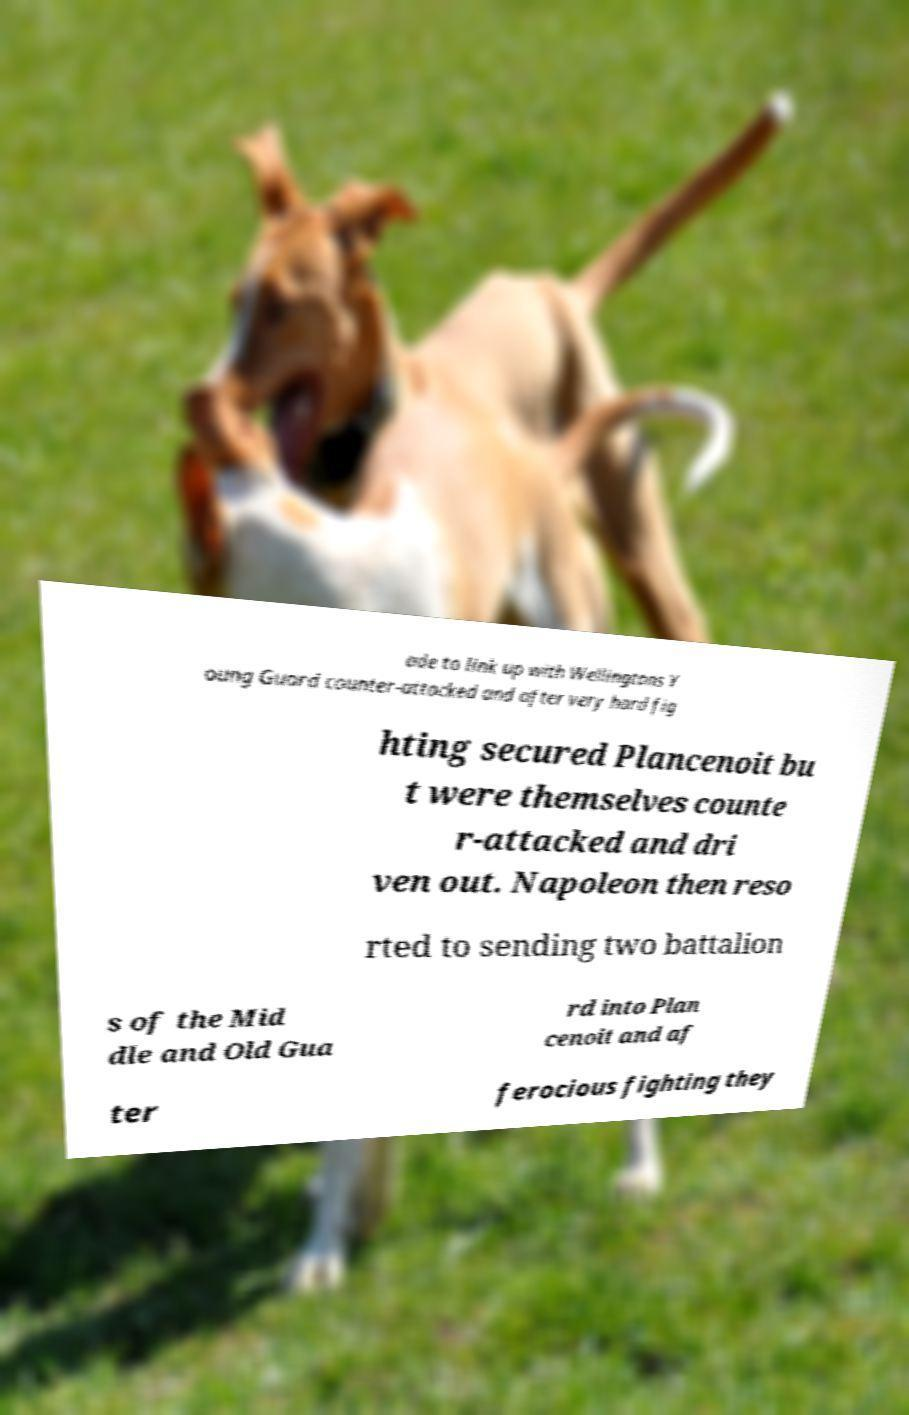Please read and relay the text visible in this image. What does it say? ade to link up with Wellingtons Y oung Guard counter-attacked and after very hard fig hting secured Plancenoit bu t were themselves counte r-attacked and dri ven out. Napoleon then reso rted to sending two battalion s of the Mid dle and Old Gua rd into Plan cenoit and af ter ferocious fighting they 